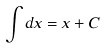Convert formula to latex. <formula><loc_0><loc_0><loc_500><loc_500>\int d x = x + C</formula> 